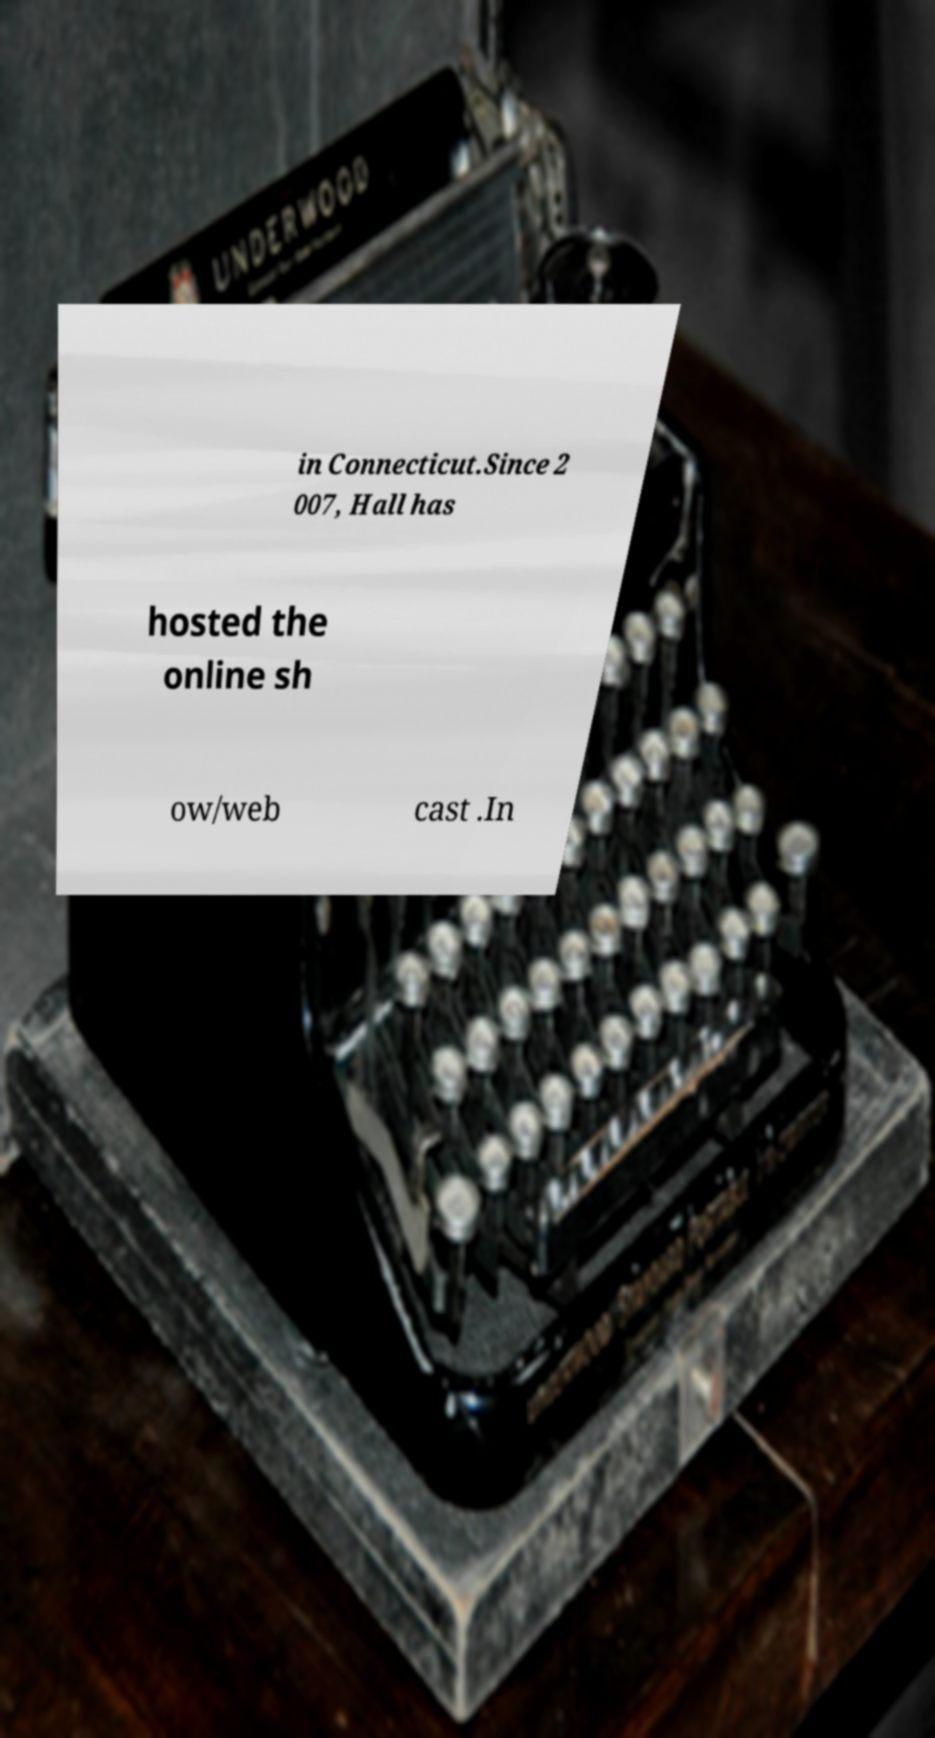Could you assist in decoding the text presented in this image and type it out clearly? in Connecticut.Since 2 007, Hall has hosted the online sh ow/web cast .In 